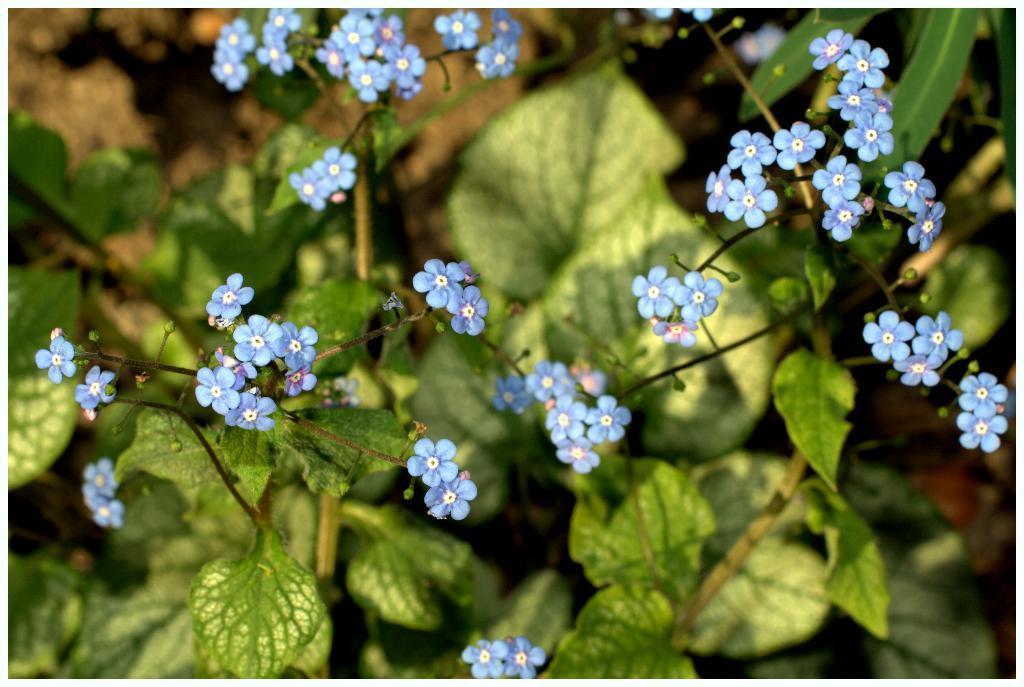In one or two sentences, can you explain what this image depicts? In this image we can see some plants with flowers on it. 